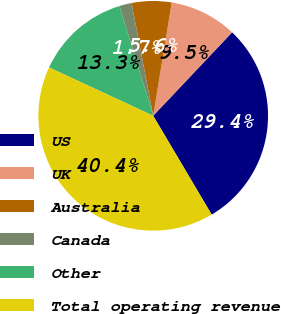<chart> <loc_0><loc_0><loc_500><loc_500><pie_chart><fcel>US<fcel>UK<fcel>Australia<fcel>Canada<fcel>Other<fcel>Total operating revenue<nl><fcel>29.45%<fcel>9.47%<fcel>5.6%<fcel>1.73%<fcel>13.34%<fcel>40.43%<nl></chart> 